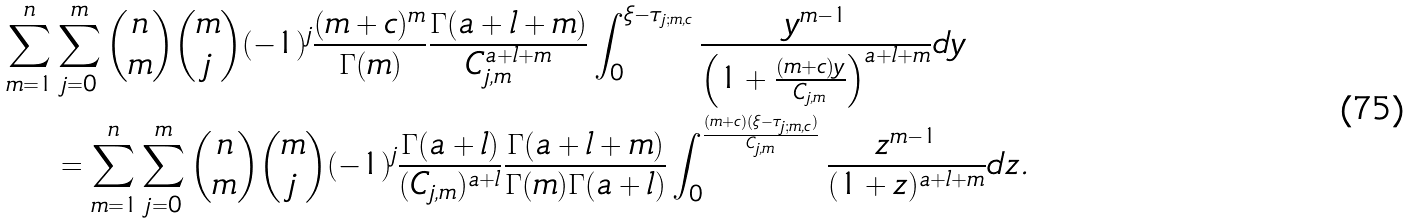Convert formula to latex. <formula><loc_0><loc_0><loc_500><loc_500>\sum _ { m = 1 } ^ { n } & \sum _ { j = 0 } ^ { m } \binom { n } { m } \binom { m } { j } ( - 1 ) ^ { j } \frac { ( m + c ) ^ { m } } { \Gamma ( m ) } \frac { \Gamma { ( a + l + m ) } } { C _ { j , m } ^ { a + l + m } } \int _ { 0 } ^ { \xi - \tau _ { j ; m , c } } \frac { y ^ { m - 1 } } { \left ( 1 + \frac { ( m + c ) y } { C _ { j , m } } \right ) ^ { a + l + m } } d y \\ & = \sum _ { m = 1 } ^ { n } \sum _ { j = 0 } ^ { m } \binom { n } { m } \binom { m } { j } ( - 1 ) ^ { j } \frac { \Gamma { ( a + l ) } } { ( C _ { j , m } ) ^ { a + l } } \frac { \Gamma { ( a + l + m ) } } { \Gamma ( m ) \Gamma { ( a + l ) } } \int _ { 0 } ^ { \frac { ( m + c ) ( \xi - \tau _ { j ; m , c } ) } { C _ { j , m } } } \frac { z ^ { m - 1 } } { ( 1 + z ) ^ { a + l + m } } d z .</formula> 